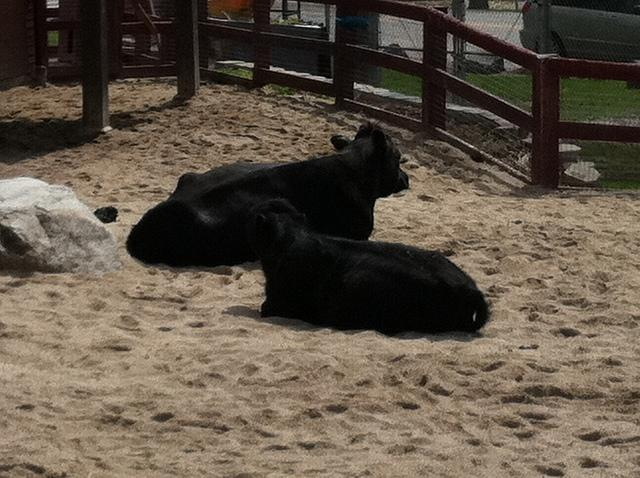What are the cows inside of? pen 